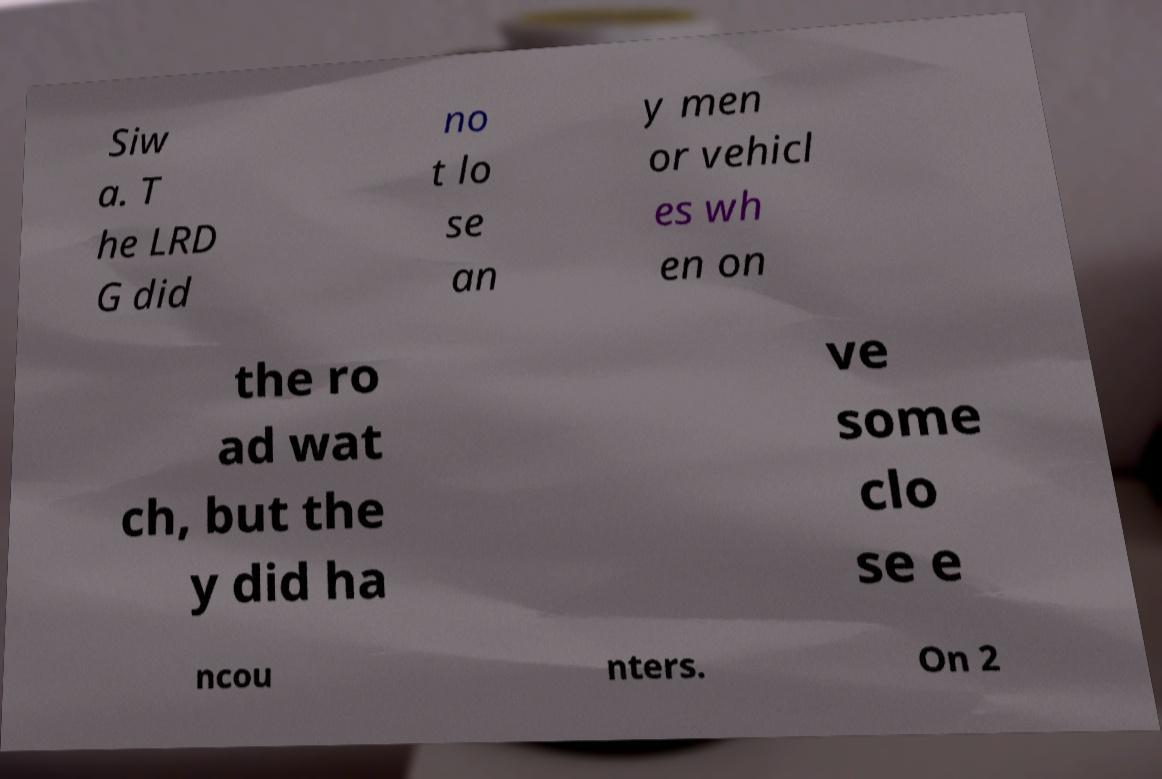Please read and relay the text visible in this image. What does it say? Siw a. T he LRD G did no t lo se an y men or vehicl es wh en on the ro ad wat ch, but the y did ha ve some clo se e ncou nters. On 2 